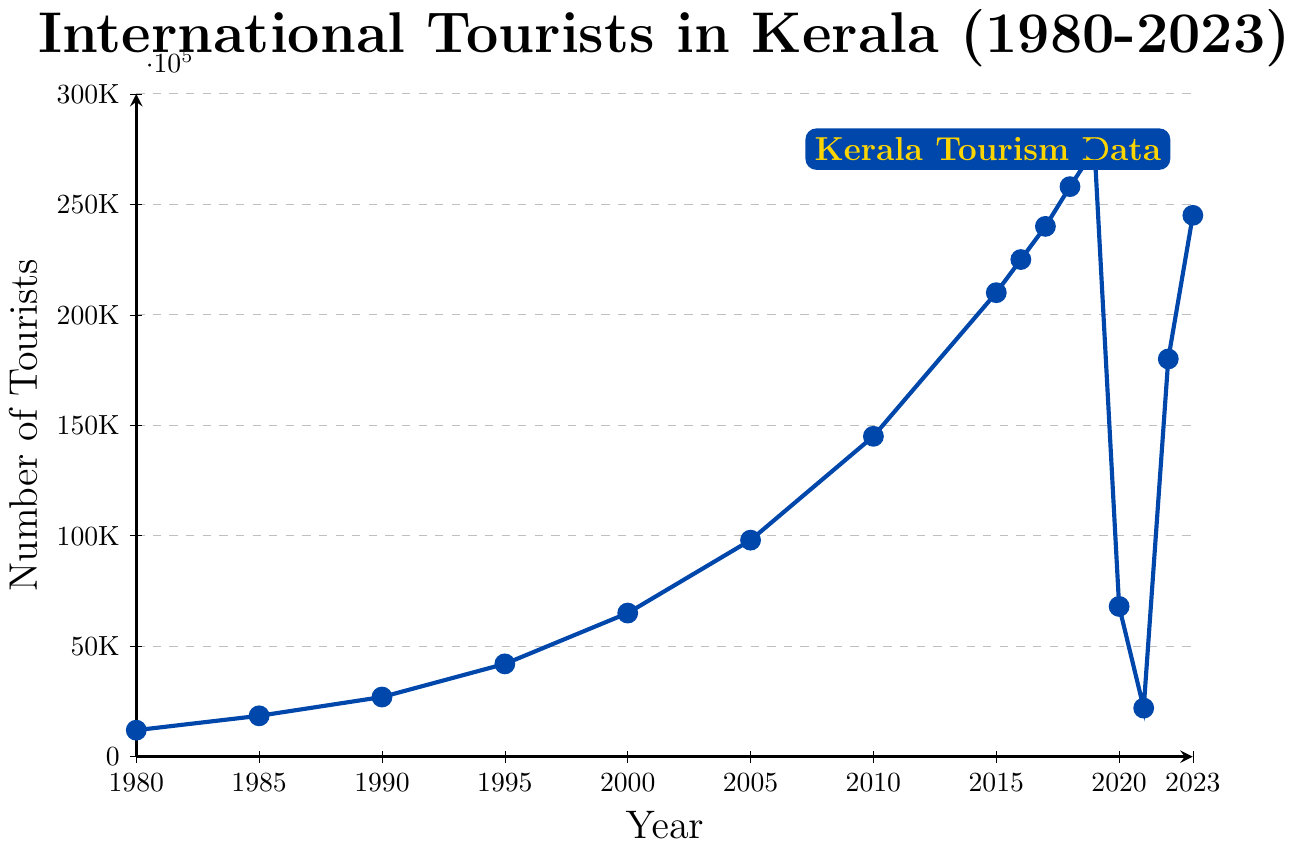What's the trend in the number of international tourists visiting Kerala from 1980 to 2023? From the figure, the number of tourists consistently increased from 1980 to 2019, with steep growth particularly between 2000 and 2019. However, there's a sharp drop in 2020 and 2021, followed by a recovery in 2022 and 2023.
Answer: Increasing with a drop in 2020 and 2021 What is the highest number of international tourists recorded in a single year? According to the figure, the peak number of tourists was in 2019 where it reached 275,000 tourists.
Answer: 275,000 in 2019 How did the number of tourists in 2020 compare to the number of tourists in 2019? To compare, look at the values for 2019 and 2020; in 2019, there were 275,000 tourists, and in 2020, there were only 68,000 tourists. This indicates a significant drop.
Answer: Decreased by 207,000 What is the percentage increase in the number of tourists from 1980 to 2019? Calculate the difference between the numbers in 2019 (275,000) and 1980 (12,000), then divide by the 1980 figure and multiply by 100 to get the percentage. ((275,000 - 12,000) / 12,000) * 100 = 2191.67%
Answer: 2191.67% What was the impact of the COVID-19 pandemic on international tourism in Kerala? The number of tourists fell drastically from 275,000 in 2019 to 68,000 in 2020 and further down to 22,000 in 2021. This suggests a significant impact due to the pandemic.
Answer: Drastic decrease in 2020 and 2021 From which year did the number of international tourists consistently stay above 200,000 until 2023? Observing the figure, it is evident that from 2015 onwards, the number remains above 200,000 until 2023, except for the dip during the pandemic years (2020 and 2021).
Answer: 2015 What can be observed about the yearly fluctuations between 2015 and 2019? During these years, the number of tourists increased steadily year-on-year: 2015 had 210,000, 2016 had 225,000, 2017 had 240,000, 2018 had 258,000, and 2019 had 275,000.
Answer: Steady increase What was the number of international tourists in 2023 compared to 2022? Look at the values for 2022 and 2023; in 2022 there were 180,000 tourists and in 2023, the number increased to 245,000.
Answer: Increased by 65,000 Which color represents the data line for international tourists in the figure? The line representing the number of international tourists is colored blue. There is no other additional color for comparison in the chart.
Answer: Blue 